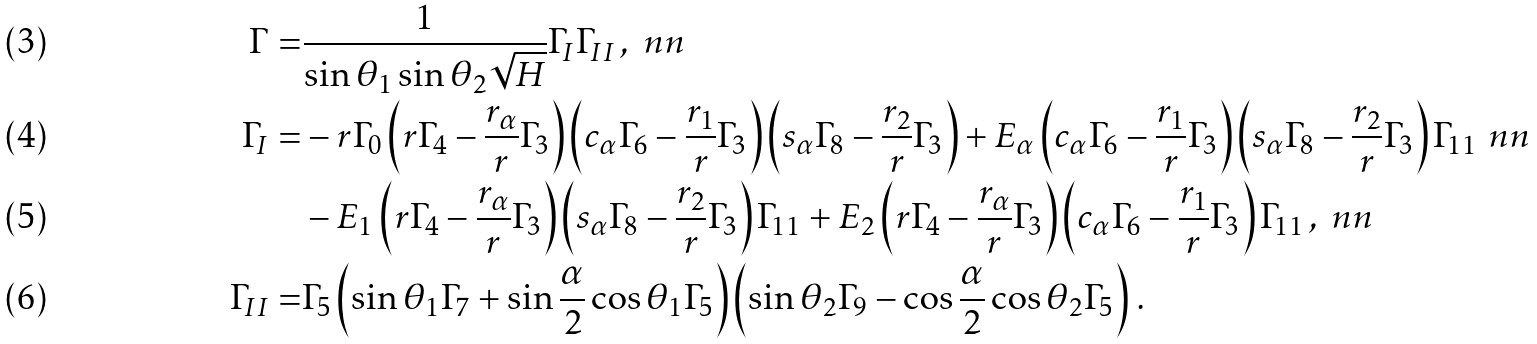<formula> <loc_0><loc_0><loc_500><loc_500>\Gamma = & \frac { 1 } { \sin \theta _ { 1 } \sin \theta _ { 2 } \sqrt { H } } \Gamma _ { I } \Gamma _ { I I } \, , \ n n \\ \Gamma _ { I } = & - r \Gamma _ { 0 } \left ( r \Gamma _ { 4 } - \frac { r _ { \alpha } } { r } \Gamma _ { 3 } \right ) \left ( c _ { \alpha } \Gamma _ { 6 } - \frac { r _ { 1 } } { r } \Gamma _ { 3 } \right ) \left ( s _ { \alpha } \Gamma _ { 8 } - \frac { r _ { 2 } } { r } \Gamma _ { 3 } \right ) + E _ { \alpha } \left ( c _ { \alpha } \Gamma _ { 6 } - \frac { r _ { 1 } } { r } \Gamma _ { 3 } \right ) \left ( s _ { \alpha } \Gamma _ { 8 } - \frac { r _ { 2 } } { r } \Gamma _ { 3 } \right ) \Gamma _ { 1 1 } \ n n \\ & - E _ { 1 } \left ( r \Gamma _ { 4 } - \frac { r _ { \alpha } } { r } \Gamma _ { 3 } \right ) \left ( s _ { \alpha } \Gamma _ { 8 } - \frac { r _ { 2 } } { r } \Gamma _ { 3 } \right ) \Gamma _ { 1 1 } + E _ { 2 } \left ( r \Gamma _ { 4 } - \frac { r _ { \alpha } } { r } \Gamma _ { 3 } \right ) \left ( c _ { \alpha } \Gamma _ { 6 } - \frac { r _ { 1 } } { r } \Gamma _ { 3 } \right ) \Gamma _ { 1 1 } \, , \ n n \\ \Gamma _ { I I } = & \Gamma _ { 5 } \left ( \sin \theta _ { 1 } \Gamma _ { 7 } + \sin \frac { \alpha } { 2 } \cos \theta _ { 1 } \Gamma _ { 5 } \right ) \left ( \sin \theta _ { 2 } \Gamma _ { 9 } - \cos \frac { \alpha } { 2 } \cos \theta _ { 2 } \Gamma _ { 5 } \right ) \, .</formula> 